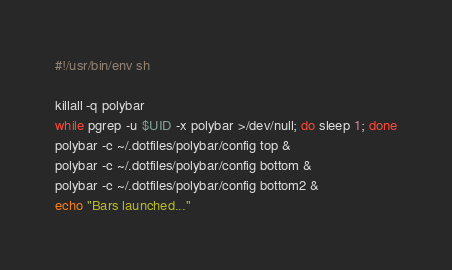<code> <loc_0><loc_0><loc_500><loc_500><_Bash_>#!/usr/bin/env sh

killall -q polybar
while pgrep -u $UID -x polybar >/dev/null; do sleep 1; done
polybar -c ~/.dotfiles/polybar/config top &
polybar -c ~/.dotfiles/polybar/config bottom &
polybar -c ~/.dotfiles/polybar/config bottom2 &
echo "Bars launched..."
</code> 